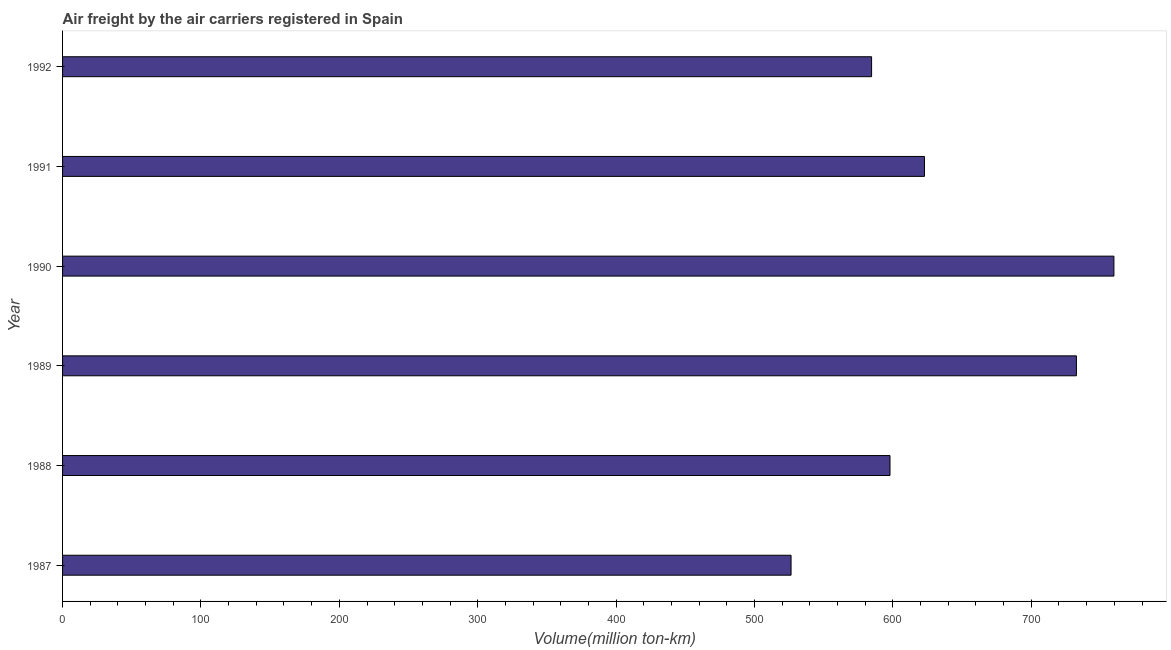Does the graph contain any zero values?
Offer a terse response. No. What is the title of the graph?
Keep it short and to the point. Air freight by the air carriers registered in Spain. What is the label or title of the X-axis?
Your answer should be compact. Volume(million ton-km). What is the label or title of the Y-axis?
Provide a succinct answer. Year. What is the air freight in 1991?
Offer a very short reply. 622.8. Across all years, what is the maximum air freight?
Offer a terse response. 759.7. Across all years, what is the minimum air freight?
Give a very brief answer. 526.4. What is the sum of the air freight?
Your response must be concise. 3824. What is the difference between the air freight in 1988 and 1989?
Offer a terse response. -134.7. What is the average air freight per year?
Provide a short and direct response. 637.33. What is the median air freight?
Offer a very short reply. 610.35. In how many years, is the air freight greater than 260 million ton-km?
Provide a short and direct response. 6. Do a majority of the years between 1987 and 1988 (inclusive) have air freight greater than 80 million ton-km?
Offer a very short reply. Yes. What is the ratio of the air freight in 1988 to that in 1990?
Your answer should be compact. 0.79. Is the air freight in 1988 less than that in 1991?
Provide a succinct answer. Yes. What is the difference between the highest and the second highest air freight?
Keep it short and to the point. 27.1. Is the sum of the air freight in 1987 and 1988 greater than the maximum air freight across all years?
Provide a succinct answer. Yes. What is the difference between the highest and the lowest air freight?
Ensure brevity in your answer.  233.3. In how many years, is the air freight greater than the average air freight taken over all years?
Ensure brevity in your answer.  2. Are all the bars in the graph horizontal?
Offer a terse response. Yes. How many years are there in the graph?
Give a very brief answer. 6. What is the difference between two consecutive major ticks on the X-axis?
Ensure brevity in your answer.  100. Are the values on the major ticks of X-axis written in scientific E-notation?
Ensure brevity in your answer.  No. What is the Volume(million ton-km) in 1987?
Your response must be concise. 526.4. What is the Volume(million ton-km) of 1988?
Offer a very short reply. 597.9. What is the Volume(million ton-km) of 1989?
Your answer should be very brief. 732.6. What is the Volume(million ton-km) in 1990?
Your response must be concise. 759.7. What is the Volume(million ton-km) of 1991?
Provide a succinct answer. 622.8. What is the Volume(million ton-km) of 1992?
Provide a short and direct response. 584.6. What is the difference between the Volume(million ton-km) in 1987 and 1988?
Give a very brief answer. -71.5. What is the difference between the Volume(million ton-km) in 1987 and 1989?
Make the answer very short. -206.2. What is the difference between the Volume(million ton-km) in 1987 and 1990?
Your response must be concise. -233.3. What is the difference between the Volume(million ton-km) in 1987 and 1991?
Offer a terse response. -96.4. What is the difference between the Volume(million ton-km) in 1987 and 1992?
Give a very brief answer. -58.2. What is the difference between the Volume(million ton-km) in 1988 and 1989?
Your answer should be compact. -134.7. What is the difference between the Volume(million ton-km) in 1988 and 1990?
Ensure brevity in your answer.  -161.8. What is the difference between the Volume(million ton-km) in 1988 and 1991?
Your response must be concise. -24.9. What is the difference between the Volume(million ton-km) in 1988 and 1992?
Offer a terse response. 13.3. What is the difference between the Volume(million ton-km) in 1989 and 1990?
Your response must be concise. -27.1. What is the difference between the Volume(million ton-km) in 1989 and 1991?
Offer a very short reply. 109.8. What is the difference between the Volume(million ton-km) in 1989 and 1992?
Offer a terse response. 148. What is the difference between the Volume(million ton-km) in 1990 and 1991?
Provide a short and direct response. 136.9. What is the difference between the Volume(million ton-km) in 1990 and 1992?
Give a very brief answer. 175.1. What is the difference between the Volume(million ton-km) in 1991 and 1992?
Give a very brief answer. 38.2. What is the ratio of the Volume(million ton-km) in 1987 to that in 1988?
Your answer should be very brief. 0.88. What is the ratio of the Volume(million ton-km) in 1987 to that in 1989?
Keep it short and to the point. 0.72. What is the ratio of the Volume(million ton-km) in 1987 to that in 1990?
Your answer should be very brief. 0.69. What is the ratio of the Volume(million ton-km) in 1987 to that in 1991?
Your answer should be very brief. 0.84. What is the ratio of the Volume(million ton-km) in 1988 to that in 1989?
Give a very brief answer. 0.82. What is the ratio of the Volume(million ton-km) in 1988 to that in 1990?
Provide a short and direct response. 0.79. What is the ratio of the Volume(million ton-km) in 1988 to that in 1991?
Your response must be concise. 0.96. What is the ratio of the Volume(million ton-km) in 1989 to that in 1991?
Your response must be concise. 1.18. What is the ratio of the Volume(million ton-km) in 1989 to that in 1992?
Give a very brief answer. 1.25. What is the ratio of the Volume(million ton-km) in 1990 to that in 1991?
Make the answer very short. 1.22. What is the ratio of the Volume(million ton-km) in 1990 to that in 1992?
Offer a terse response. 1.3. What is the ratio of the Volume(million ton-km) in 1991 to that in 1992?
Keep it short and to the point. 1.06. 